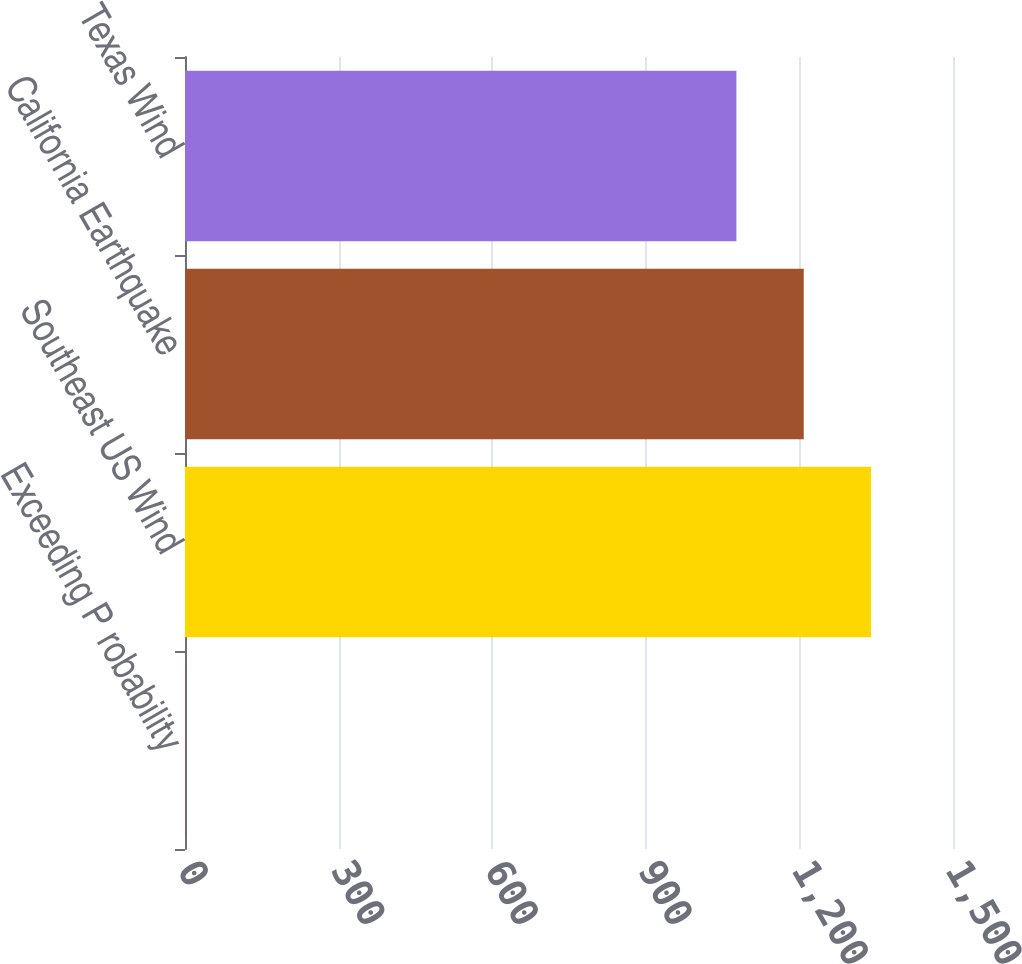Convert chart. <chart><loc_0><loc_0><loc_500><loc_500><bar_chart><fcel>Exceeding P robability<fcel>Southeast US Wind<fcel>California Earthquake<fcel>Texas Wind<nl><fcel>0.4<fcel>1339.92<fcel>1208.46<fcel>1077<nl></chart> 